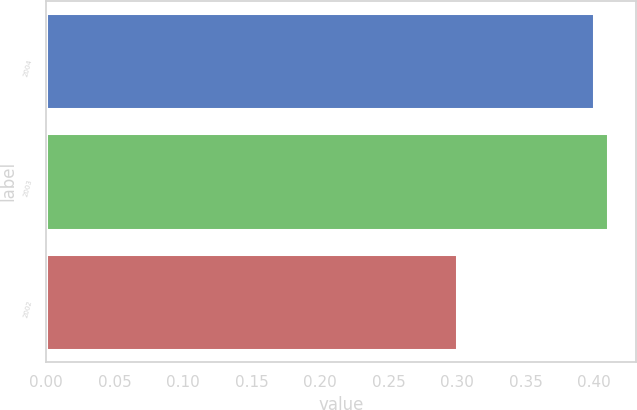<chart> <loc_0><loc_0><loc_500><loc_500><bar_chart><fcel>2004<fcel>2003<fcel>2002<nl><fcel>0.4<fcel>0.41<fcel>0.3<nl></chart> 